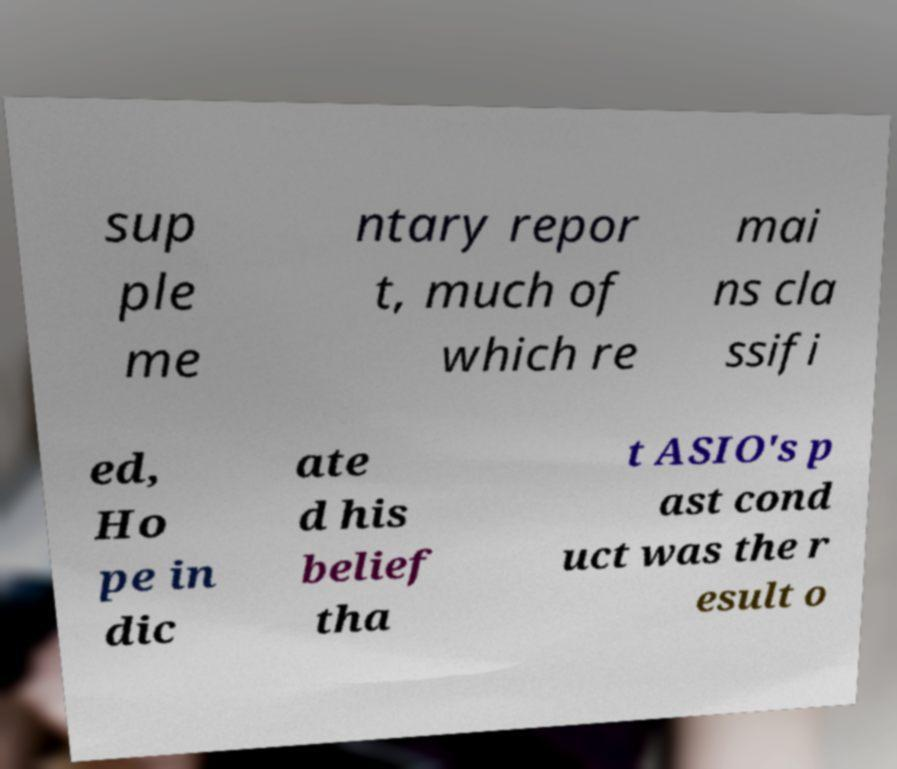There's text embedded in this image that I need extracted. Can you transcribe it verbatim? sup ple me ntary repor t, much of which re mai ns cla ssifi ed, Ho pe in dic ate d his belief tha t ASIO's p ast cond uct was the r esult o 